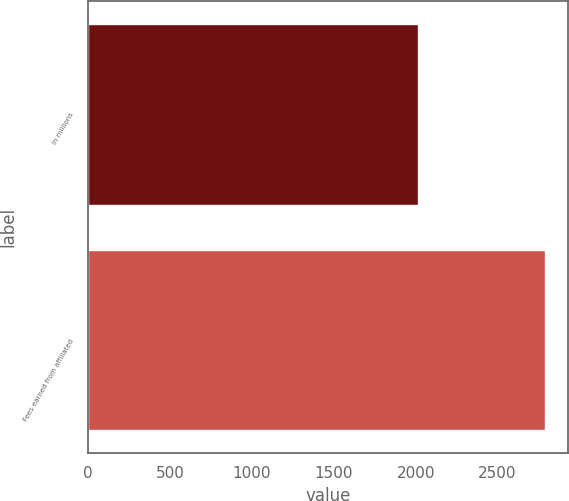<chart> <loc_0><loc_0><loc_500><loc_500><bar_chart><fcel>in millions<fcel>Fees earned from affiliated<nl><fcel>2011<fcel>2789<nl></chart> 